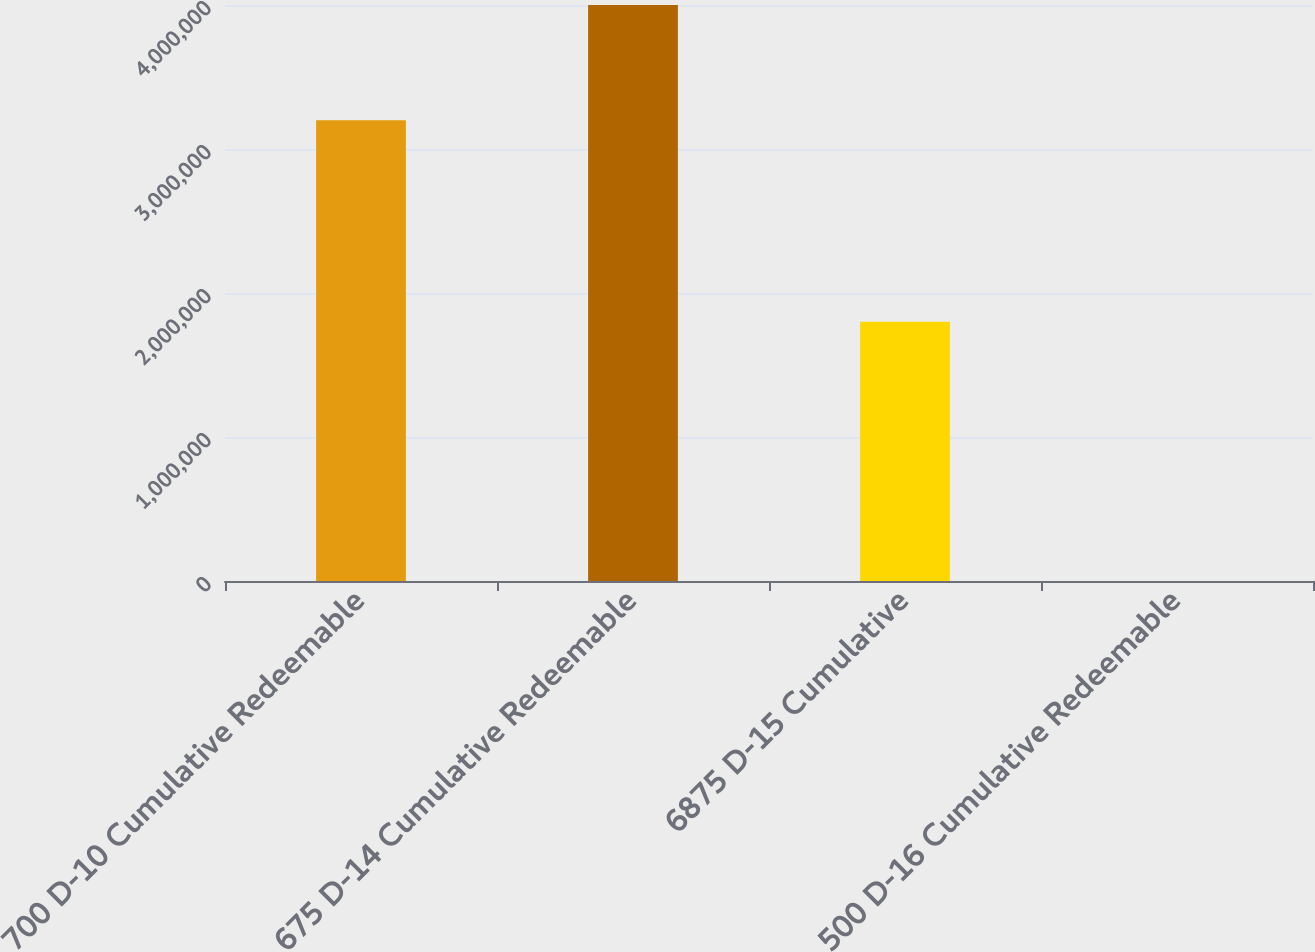Convert chart to OTSL. <chart><loc_0><loc_0><loc_500><loc_500><bar_chart><fcel>700 D-10 Cumulative Redeemable<fcel>675 D-14 Cumulative Redeemable<fcel>6875 D-15 Cumulative<fcel>500 D-16 Cumulative Redeemable<nl><fcel>3.2e+06<fcel>4e+06<fcel>1.8e+06<fcel>1<nl></chart> 